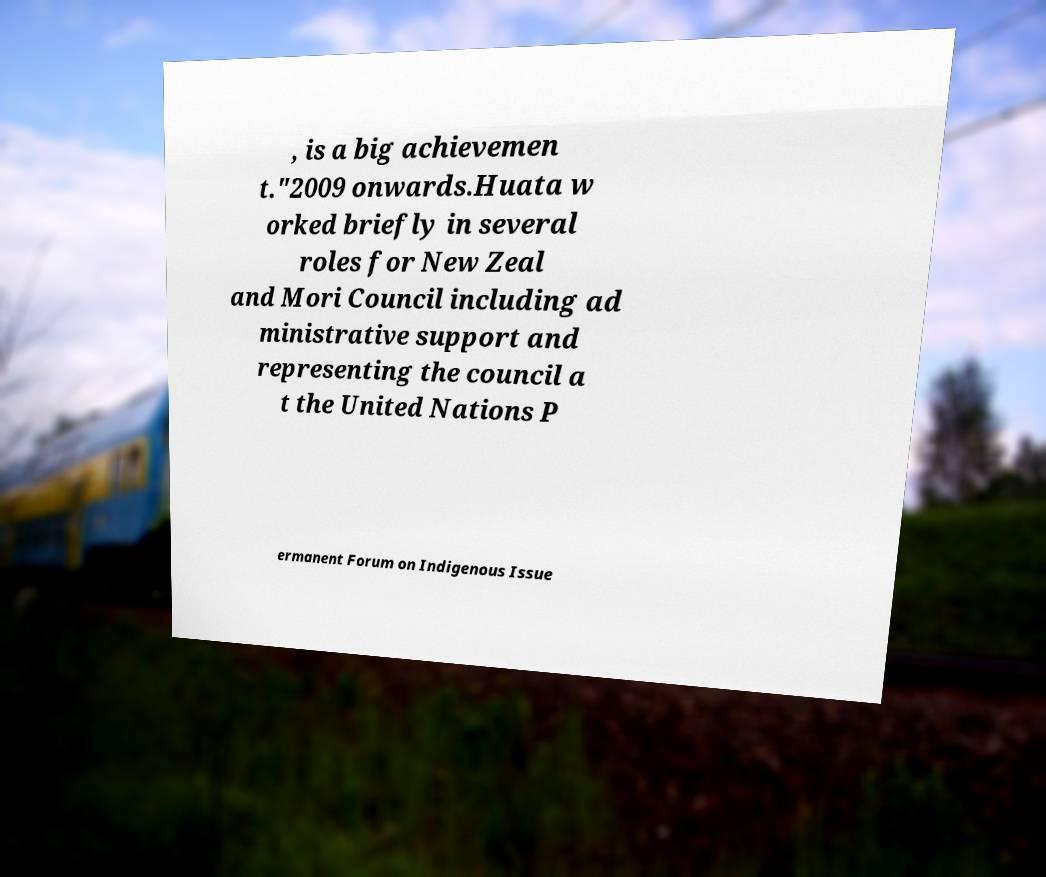Please read and relay the text visible in this image. What does it say? , is a big achievemen t."2009 onwards.Huata w orked briefly in several roles for New Zeal and Mori Council including ad ministrative support and representing the council a t the United Nations P ermanent Forum on Indigenous Issue 